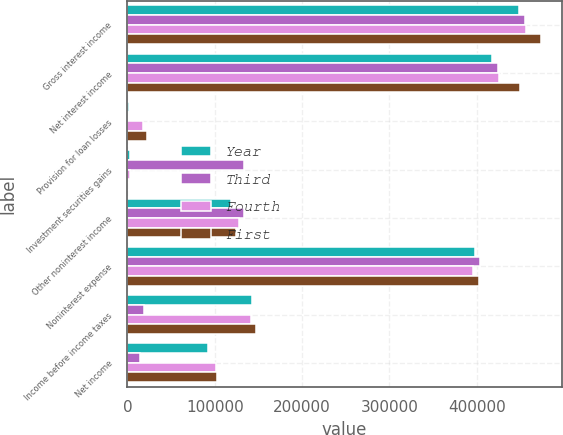Convert chart. <chart><loc_0><loc_0><loc_500><loc_500><stacked_bar_chart><ecel><fcel>Gross interest income<fcel>Net interest income<fcel>Provision for loan losses<fcel>Investment securities gains<fcel>Other noninterest income<fcel>Noninterest expense<fcel>Income before income taxes<fcel>Net income<nl><fcel>Year<fcel>448446<fcel>417346<fcel>1494<fcel>3114<fcel>118708<fcel>397461<fcel>143201<fcel>92025<nl><fcel>Third<fcel>455236<fcel>423704<fcel>566<fcel>133597<fcel>134018<fcel>404100<fcel>19459<fcel>13960<nl><fcel>Fourth<fcel>456230<fcel>425377<fcel>18262<fcel>3577<fcel>127236<fcel>396149<fcel>141779<fcel>100999<nl><fcel>First<fcel>473559<fcel>448833<fcel>22701<fcel>46<fcel>124018<fcel>402776<fcel>147420<fcel>102487<nl></chart> 